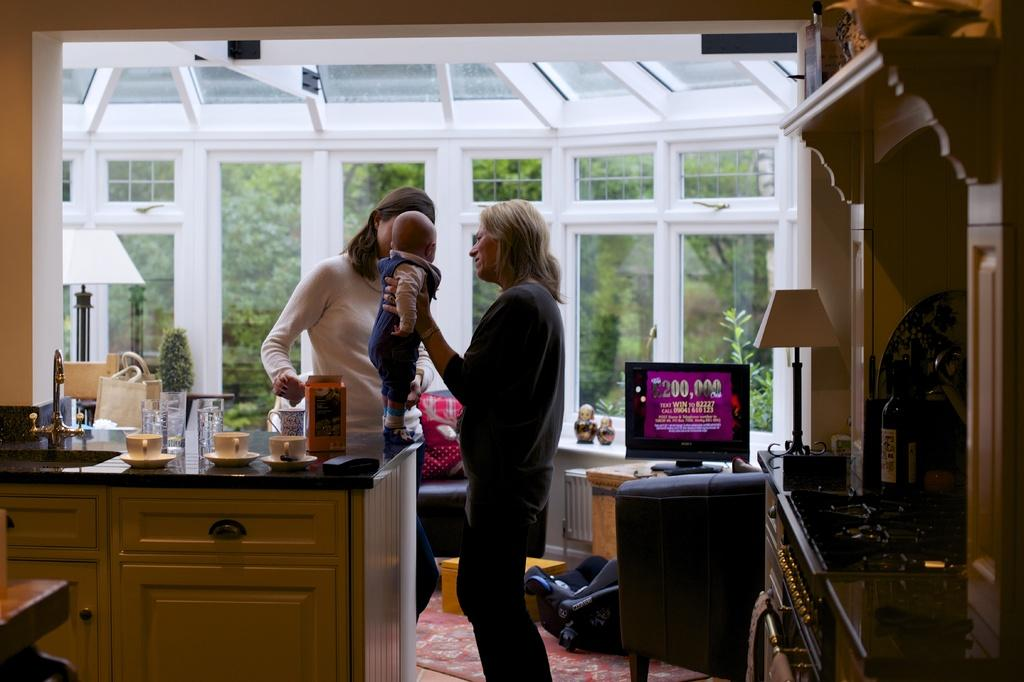How many people are in the image? There are two women in the image. What is one of the women doing with her hands? One of the women is holding a baby. What else can be seen around the women in the image? There are objects placed around the women. What type of fowl can be seen smashing the objects around the women in the image? There is no fowl present in the image, and the objects are not being smashed. 